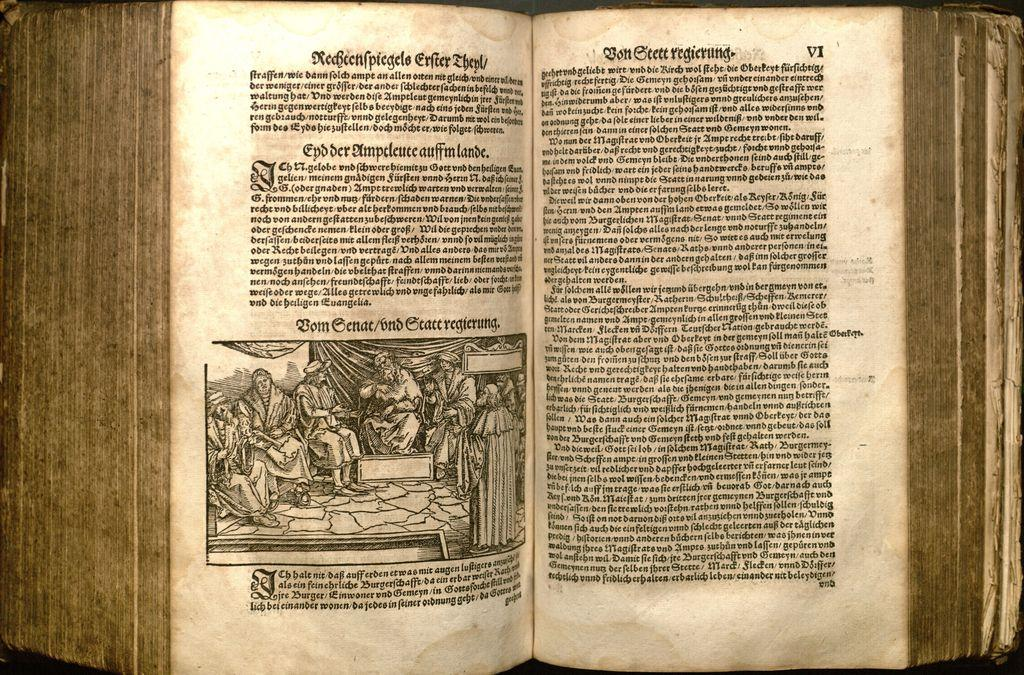<image>
Write a terse but informative summary of the picture. A very old book shows a man on a throne in Chapter 6. 